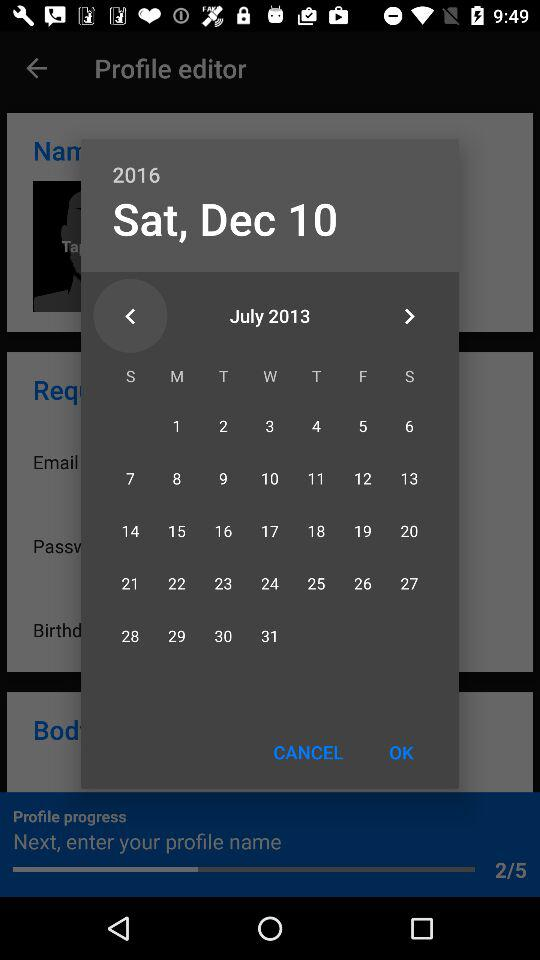What is the day selected on the calendar? The day selected on the calendar is Saturday, December 10, 2016. 